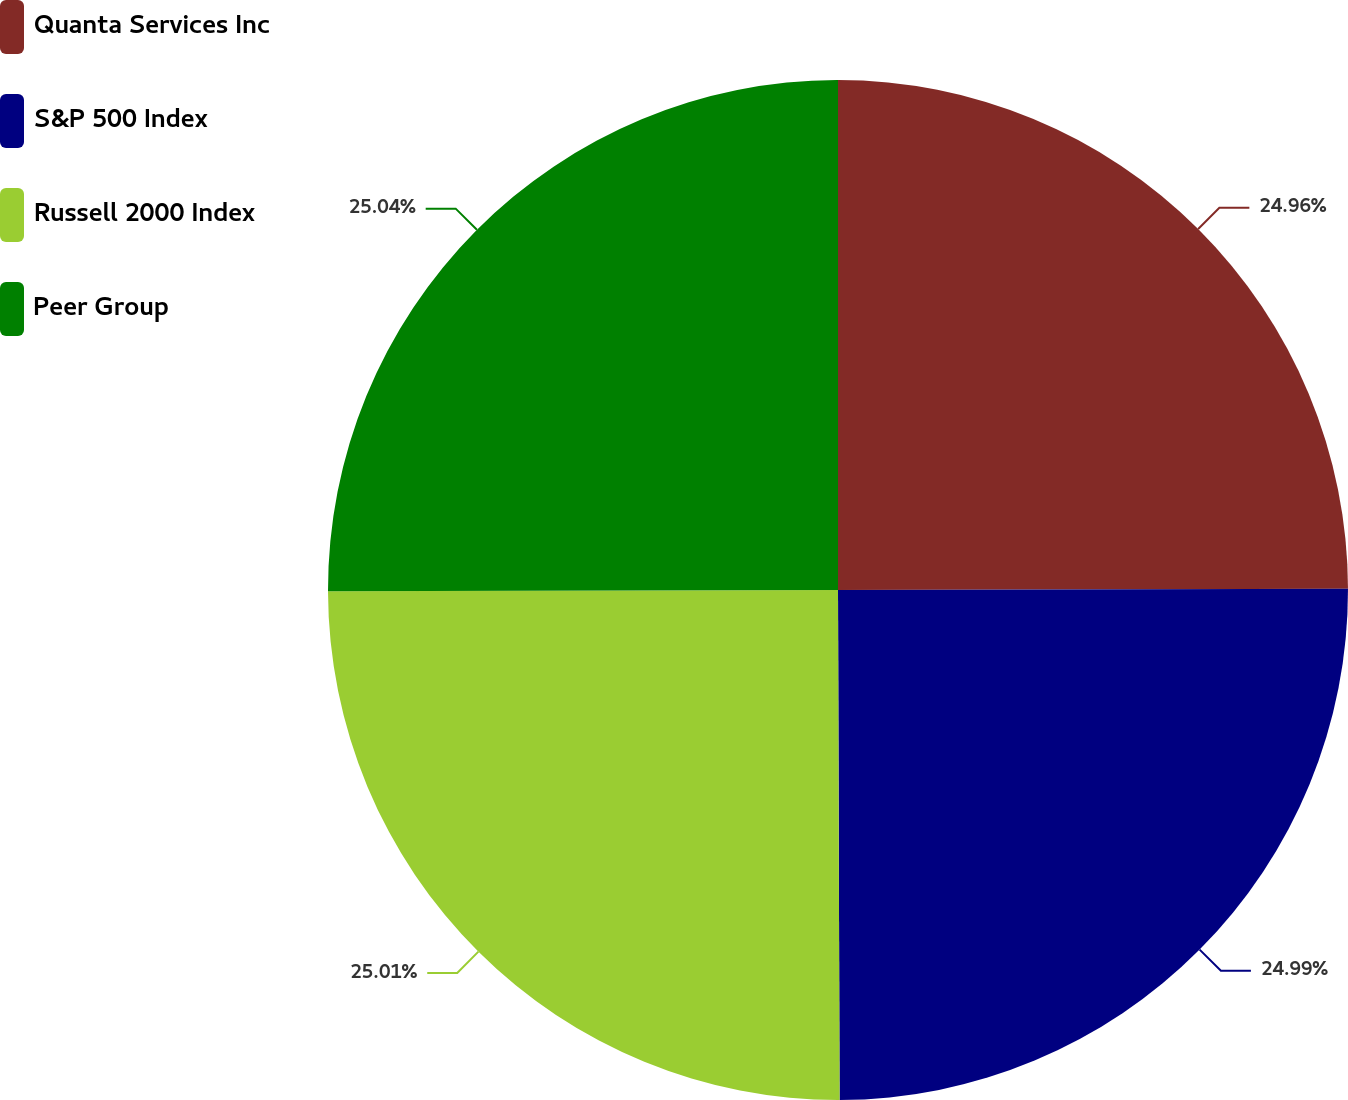Convert chart. <chart><loc_0><loc_0><loc_500><loc_500><pie_chart><fcel>Quanta Services Inc<fcel>S&P 500 Index<fcel>Russell 2000 Index<fcel>Peer Group<nl><fcel>24.96%<fcel>24.99%<fcel>25.01%<fcel>25.04%<nl></chart> 